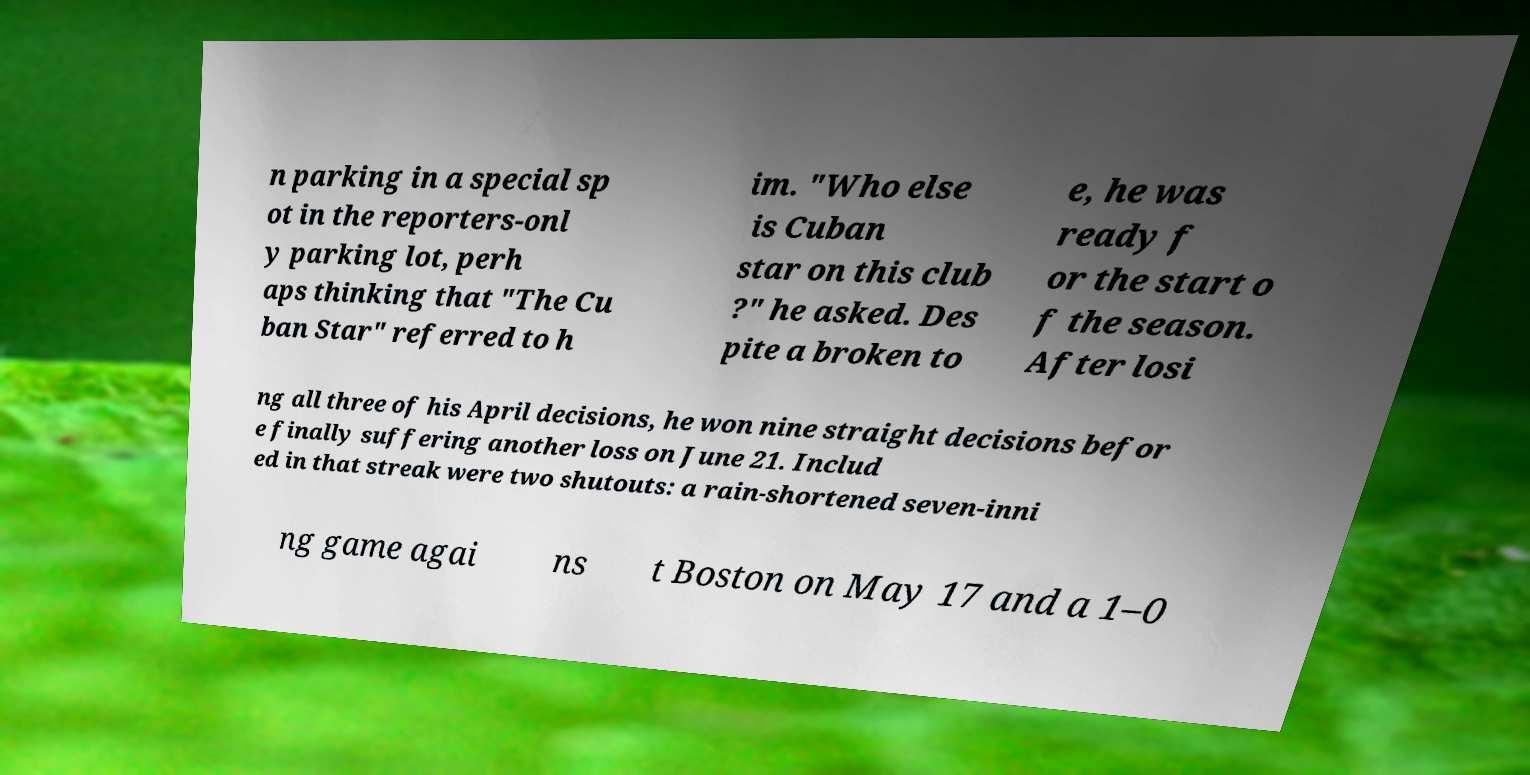Please identify and transcribe the text found in this image. n parking in a special sp ot in the reporters-onl y parking lot, perh aps thinking that "The Cu ban Star" referred to h im. "Who else is Cuban star on this club ?" he asked. Des pite a broken to e, he was ready f or the start o f the season. After losi ng all three of his April decisions, he won nine straight decisions befor e finally suffering another loss on June 21. Includ ed in that streak were two shutouts: a rain-shortened seven-inni ng game agai ns t Boston on May 17 and a 1–0 